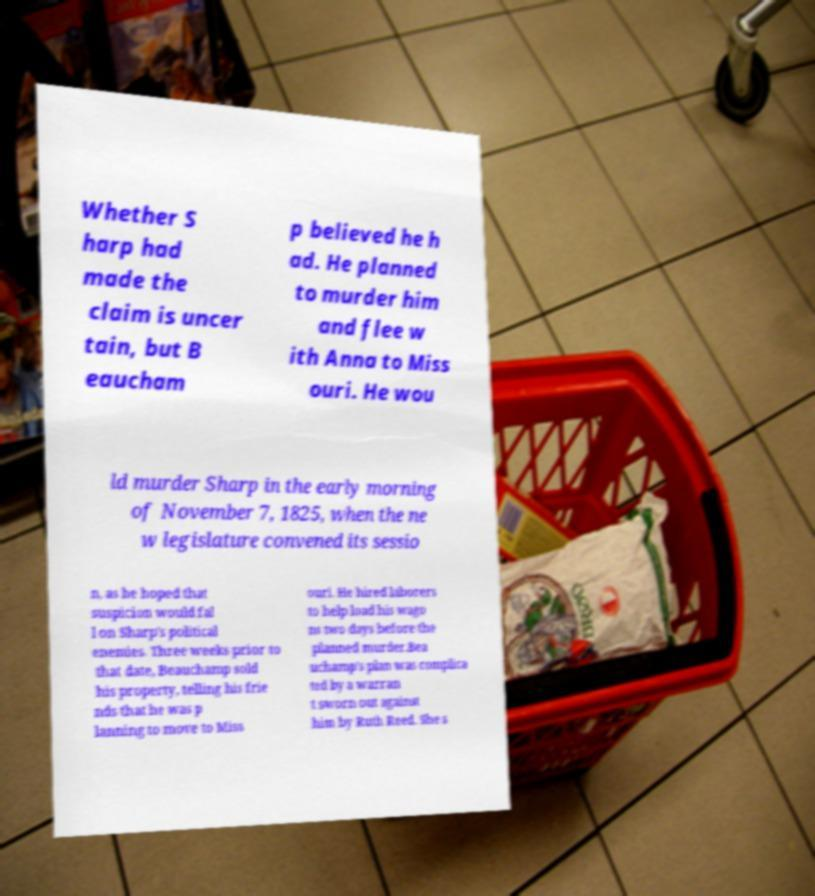What messages or text are displayed in this image? I need them in a readable, typed format. Whether S harp had made the claim is uncer tain, but B eaucham p believed he h ad. He planned to murder him and flee w ith Anna to Miss ouri. He wou ld murder Sharp in the early morning of November 7, 1825, when the ne w legislature convened its sessio n, as he hoped that suspicion would fal l on Sharp's political enemies. Three weeks prior to that date, Beauchamp sold his property, telling his frie nds that he was p lanning to move to Miss ouri. He hired laborers to help load his wago ns two days before the planned murder.Bea uchamp's plan was complica ted by a warran t sworn out against him by Ruth Reed. She s 